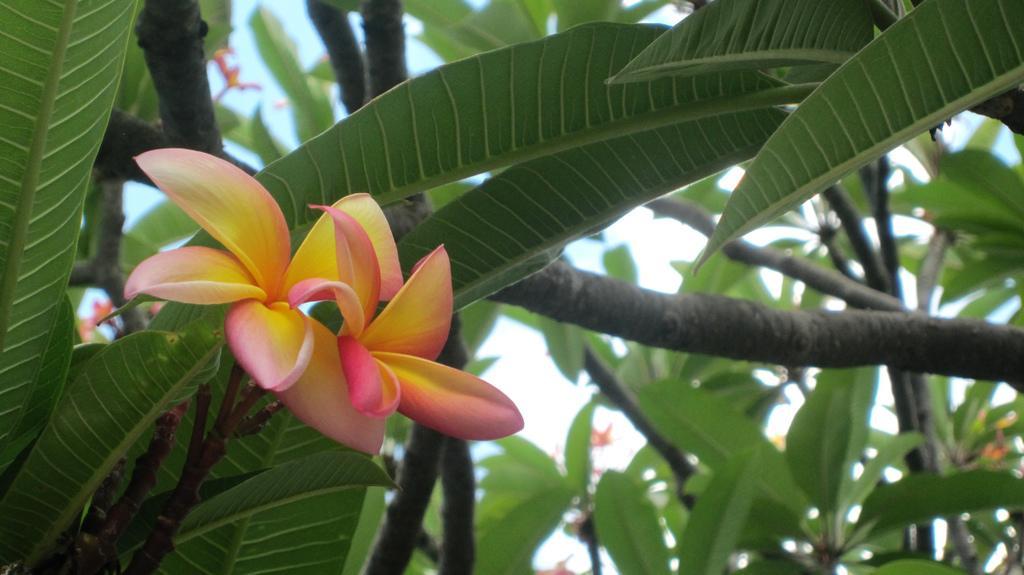How would you summarize this image in a sentence or two? In this picture I can observe a flower which is in pink and yellow color to the tree. In the background I can observe trees and a sky. 